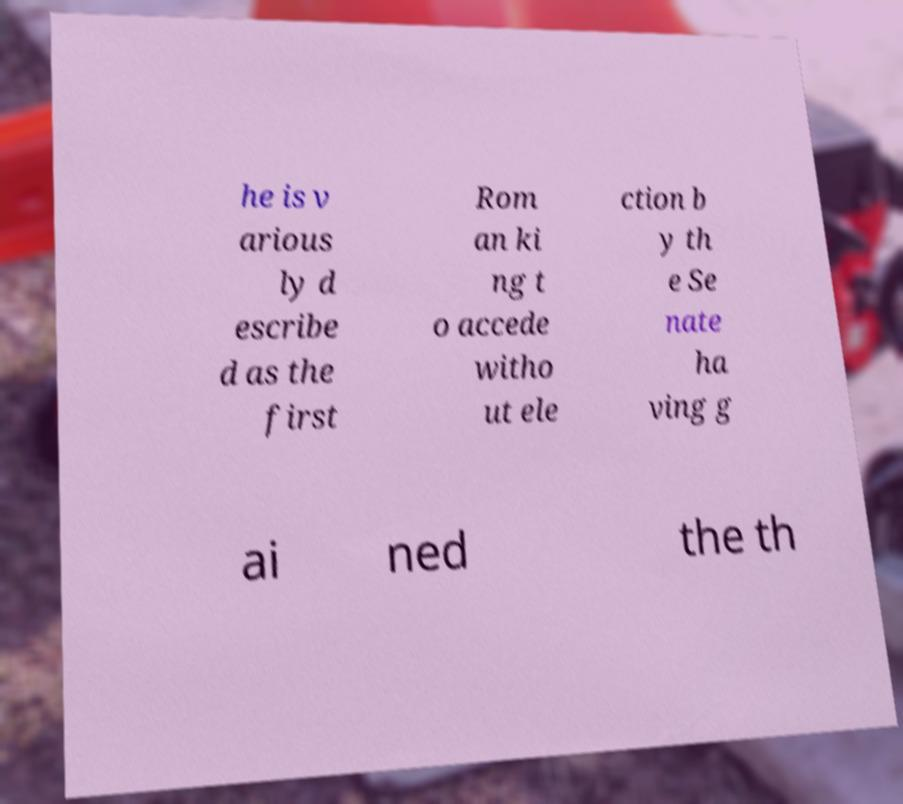Please identify and transcribe the text found in this image. he is v arious ly d escribe d as the first Rom an ki ng t o accede witho ut ele ction b y th e Se nate ha ving g ai ned the th 